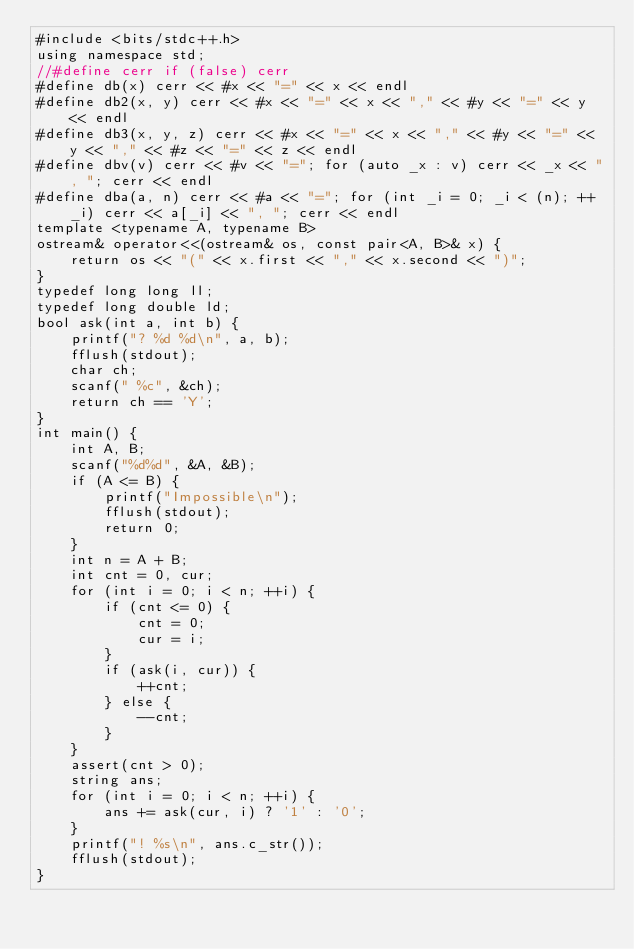<code> <loc_0><loc_0><loc_500><loc_500><_C++_>#include <bits/stdc++.h>
using namespace std;
//#define cerr if (false) cerr
#define db(x) cerr << #x << "=" << x << endl
#define db2(x, y) cerr << #x << "=" << x << "," << #y << "=" << y << endl
#define db3(x, y, z) cerr << #x << "=" << x << "," << #y << "=" << y << "," << #z << "=" << z << endl
#define dbv(v) cerr << #v << "="; for (auto _x : v) cerr << _x << ", "; cerr << endl
#define dba(a, n) cerr << #a << "="; for (int _i = 0; _i < (n); ++_i) cerr << a[_i] << ", "; cerr << endl
template <typename A, typename B>
ostream& operator<<(ostream& os, const pair<A, B>& x) {
	return os << "(" << x.first << "," << x.second << ")";
}
typedef long long ll;
typedef long double ld;
bool ask(int a, int b) {
	printf("? %d %d\n", a, b);
	fflush(stdout);
	char ch;
	scanf(" %c", &ch);
	return ch == 'Y';
}
int main() {
	int A, B;
	scanf("%d%d", &A, &B);
	if (A <= B) {
		printf("Impossible\n");
		fflush(stdout);
		return 0;
	}
	int n = A + B;
	int cnt = 0, cur;
	for (int i = 0; i < n; ++i) {
		if (cnt <= 0) {
			cnt = 0;
			cur = i;
		}
		if (ask(i, cur)) {
			++cnt;
		} else {
			--cnt;
		}
	}
	assert(cnt > 0);
	string ans;
	for (int i = 0; i < n; ++i) {
		ans += ask(cur, i) ? '1' : '0';
	}
	printf("! %s\n", ans.c_str());
	fflush(stdout);
}
</code> 